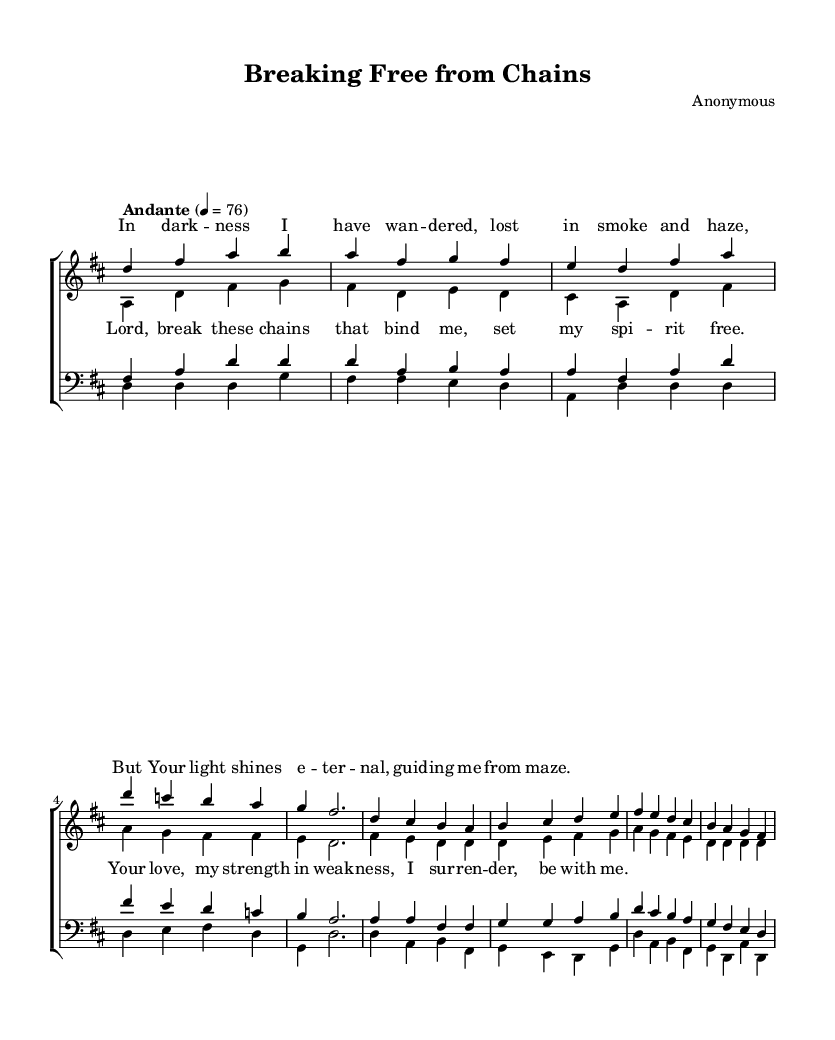What is the key signature of this music? The key signature is indicated by the sharp symbols at the beginning of the staff. There are two sharps, which correspond to F# and C#, indicating that this piece is in D major.
Answer: D major What is the time signature of this music? The time signature is shown as a fraction at the beginning of the piece; it reads 4/4, meaning there are four beats in each measure and the quarter note receives one beat.
Answer: 4/4 What is the tempo marking for this piece? The tempo is stated at the beginning of the score, specifically written as "Andante," which indicates a moderately slow tempo.
Answer: Andante How many vocal parts are written in this choral piece? By examining the score layout, we see distinct sections labeled for sopranos, altos, tenors, and basses, which totals four vocal parts featured in the arrangement.
Answer: Four What is the primary theme of the lyrics in this piece? The lyrics convey a message of seeking liberation and guidance in overcoming challenges, particularly addiction – reflected in phrases like "break these chains" and "set my spirit free."
Answer: Liberation How many measures are there in the soprano verse? Counting each group separated by vertical lines (bar lines) within the soprano verse, we find a total of six measures included.
Answer: Six What do the repeated lines in the chorus indicate about the piece? The repeated lines in the chorus suggest a central message meant to resonate and provide emphasis on the themes of strength and support during struggles, which is common in religious music for reinforcement and memorability.
Answer: Emphasis 